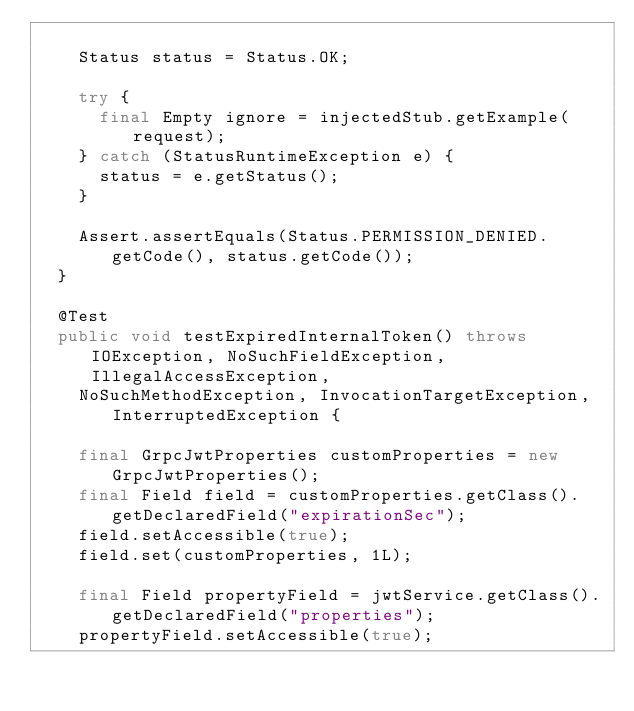Convert code to text. <code><loc_0><loc_0><loc_500><loc_500><_Java_>
		Status status = Status.OK;

		try {
			final Empty ignore = injectedStub.getExample(request);
		} catch (StatusRuntimeException e) {
			status = e.getStatus();
		}

		Assert.assertEquals(Status.PERMISSION_DENIED.getCode(), status.getCode());
	}

	@Test
	public void testExpiredInternalToken() throws IOException, NoSuchFieldException, IllegalAccessException,
		NoSuchMethodException, InvocationTargetException, InterruptedException {

		final GrpcJwtProperties customProperties = new GrpcJwtProperties();
		final Field field = customProperties.getClass().getDeclaredField("expirationSec");
		field.setAccessible(true);
		field.set(customProperties, 1L);

		final Field propertyField = jwtService.getClass().getDeclaredField("properties");
		propertyField.setAccessible(true);</code> 